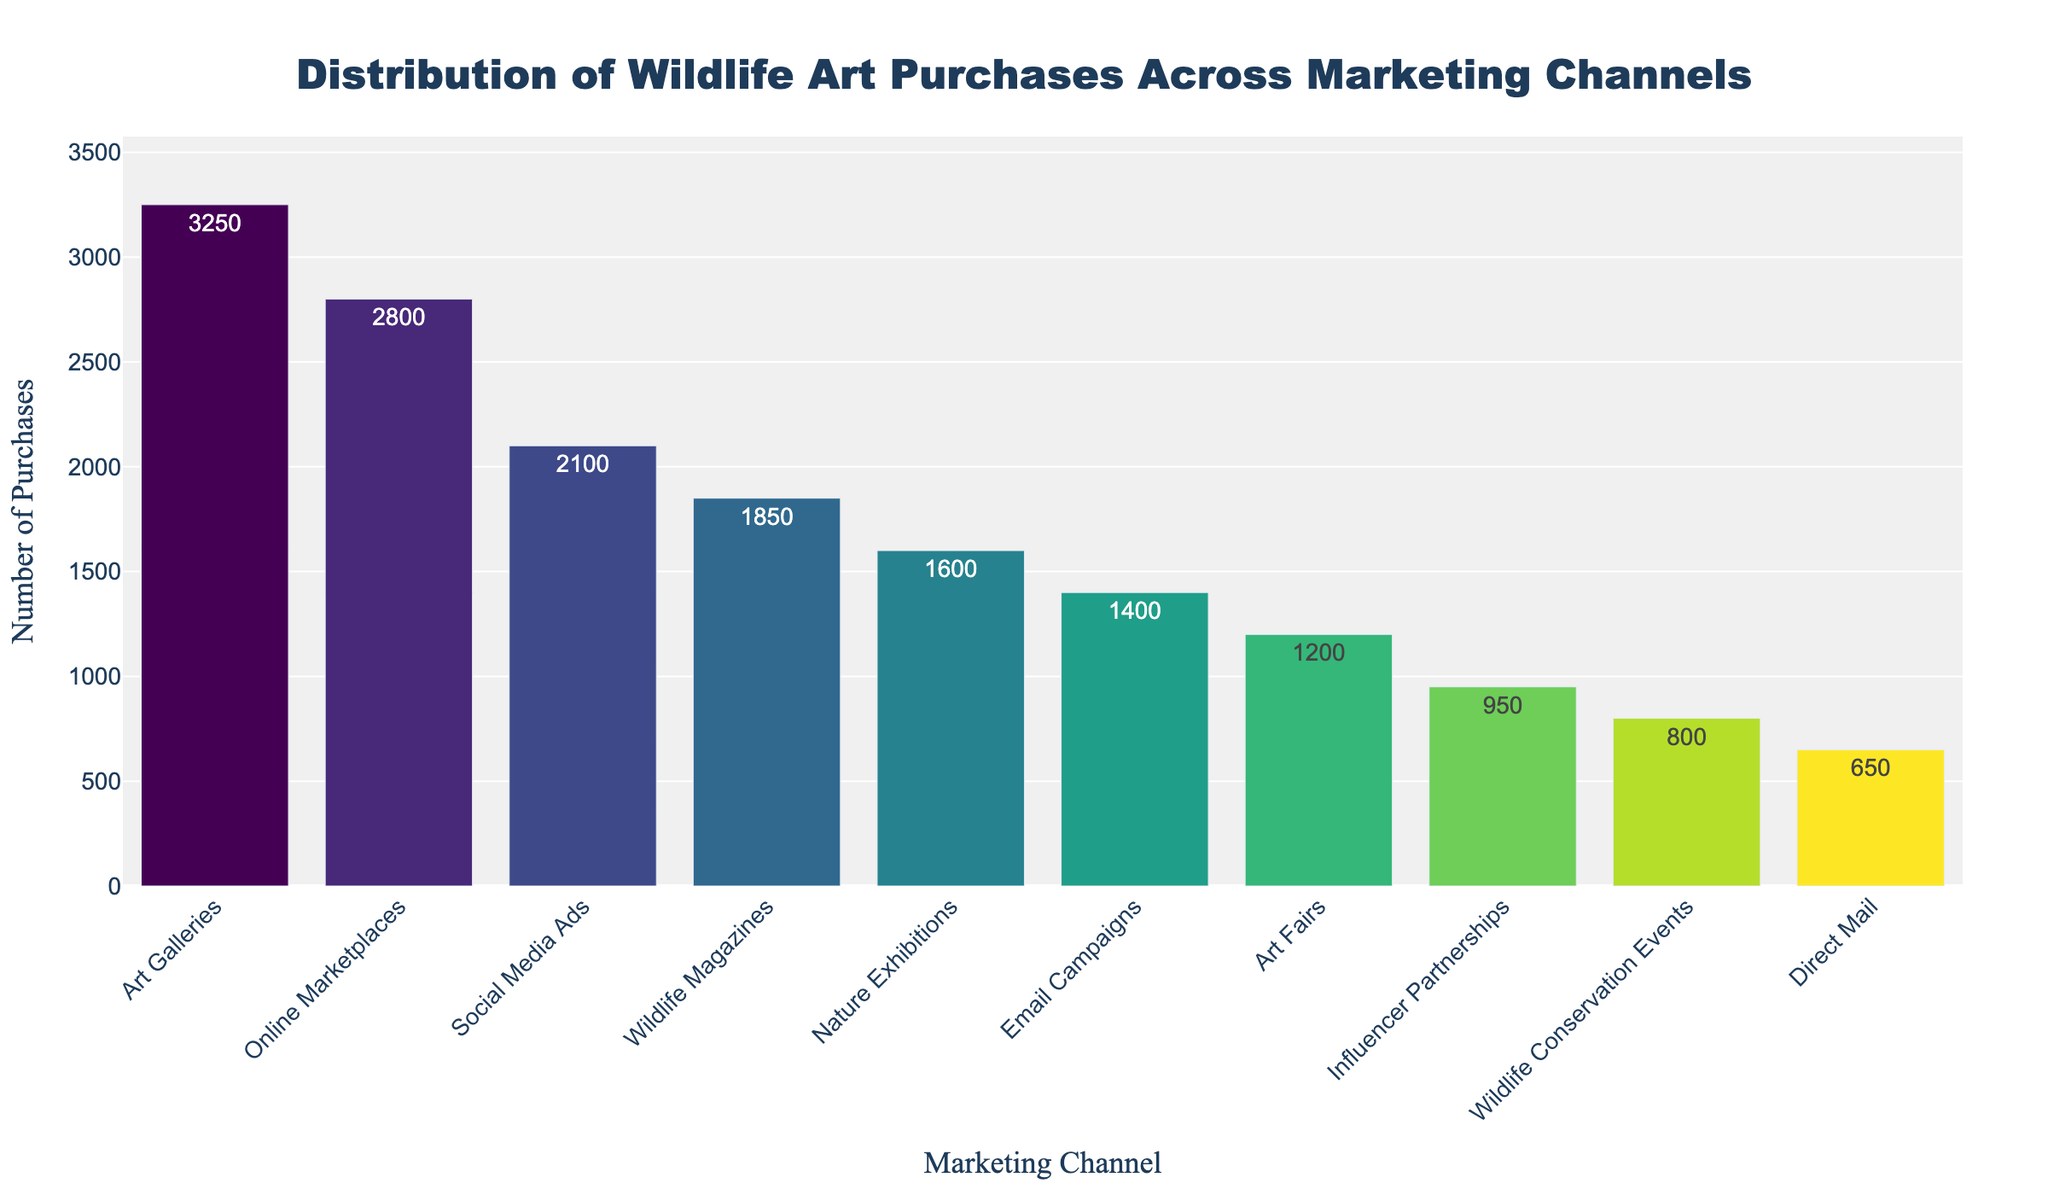Which marketing channel has the highest number of wildlife art purchases? The tallest bar in the chart corresponds to the "Art Galleries" channel, reflecting the highest number of purchases.
Answer: Art Galleries Which marketing channel has the lowest number of wildlife art purchases? The shortest bar in the chart corresponds to the "Direct Mail" channel, indicating the lowest number of purchases.
Answer: Direct Mail How many more wildlife art purchases were made through Art Galleries compared to Social Media Ads? Subtract the number of purchases in Social Media Ads (2100) from those in Art Galleries (3250): 3250 - 2100 = 1150
Answer: 1150 What is the total number of wildlife art purchases across all marketing channels? Sum up the purchases in all channels: 3250 + 2800 + 2100 + 1850 + 1600 + 1400 + 1200 + 950 + 800 + 650 = 17000
Answer: 17000 How does the number of wildlife art purchases through Email Campaigns compare to Nature Exhibitions? The bar for Email Campaigns is shorter than the bar for Nature Exhibitions, indicating fewer purchases: 1400 vs. 1600.
Answer: Nature Exhibitions > Email Campaigns What is the average number of wildlife art purchases across all channels? Divide the total purchases by the number of channels: 17000 / 10 = 1700
Answer: 1700 What is the difference in wildlife art purchases between Online Marketplaces and Influencer Partnerships? Subtract the purchases in Influencer Partnerships (950) from Online Marketplaces (2800): 2800 - 950 = 1850
Answer: 1850 What percentage of total wildlife art purchases were made through Wildlife Conservation Events? Divide the purchases in Wildlife Conservation Events (800) by the total purchases (17000) and multiply by 100: (800 / 17000) * 100 ≈ 4.71%
Answer: ~4.71% If you combine Art Galleries and Online Marketplaces, how many wildlife art purchases does that represent? Sum the purchases in Art Galleries (3250) and Online Marketplaces (2800): 3250 + 2800 = 6050
Answer: 6050 How does the total number of purchases from Social Media Ads and Wildlife Magazines compare to the total number of purchases from Nature Exhibitions and Email Campaigns? Sum the purchases: Social Media Ads (2100) + Wildlife Magazines (1850) = 3950; Nature Exhibitions (1600) + Email Campaigns (1400) = 3000. Compare 3950 and 3000.
Answer: 3950 > 3000 